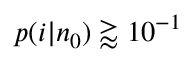<formula> <loc_0><loc_0><loc_500><loc_500>p ( i | n _ { 0 } ) \gtrapprox 1 0 ^ { - 1 }</formula> 